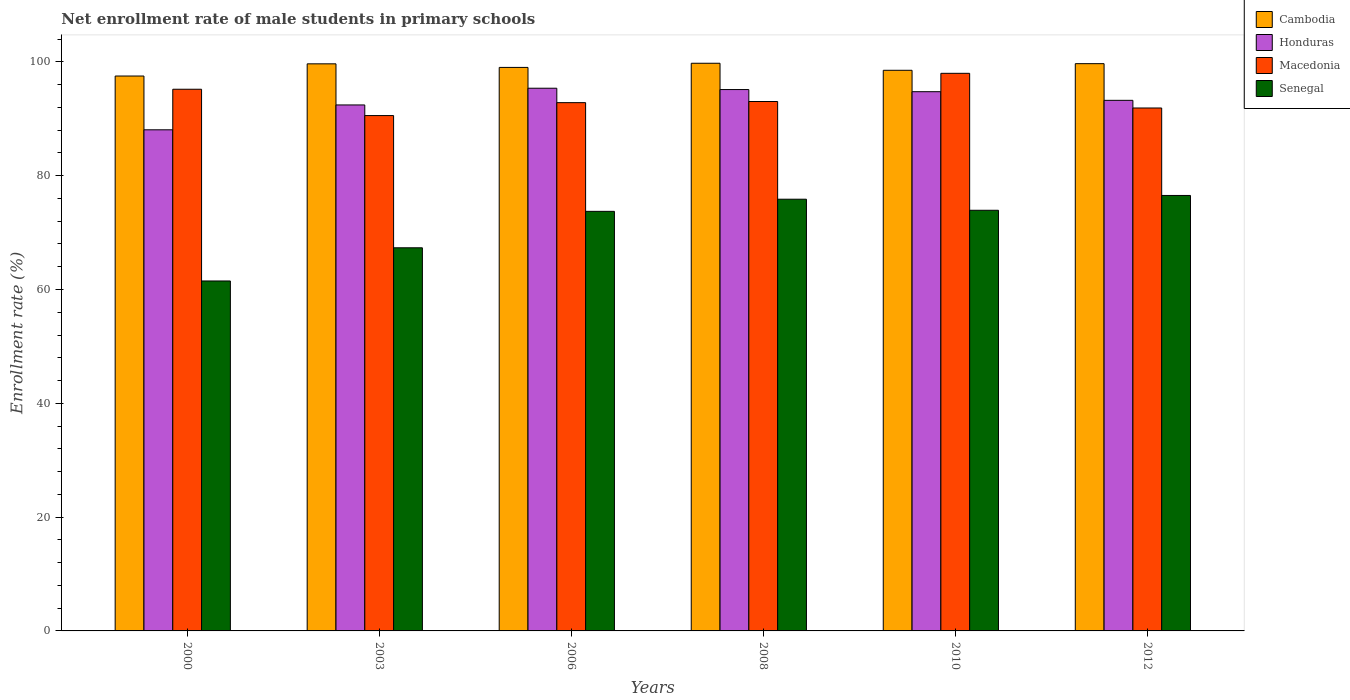How many groups of bars are there?
Offer a very short reply. 6. Are the number of bars per tick equal to the number of legend labels?
Your answer should be very brief. Yes. How many bars are there on the 5th tick from the right?
Your answer should be very brief. 4. What is the label of the 1st group of bars from the left?
Your response must be concise. 2000. What is the net enrollment rate of male students in primary schools in Macedonia in 2010?
Your answer should be very brief. 97.98. Across all years, what is the maximum net enrollment rate of male students in primary schools in Senegal?
Ensure brevity in your answer.  76.52. Across all years, what is the minimum net enrollment rate of male students in primary schools in Honduras?
Your answer should be compact. 88.06. In which year was the net enrollment rate of male students in primary schools in Senegal minimum?
Provide a succinct answer. 2000. What is the total net enrollment rate of male students in primary schools in Cambodia in the graph?
Offer a terse response. 594.13. What is the difference between the net enrollment rate of male students in primary schools in Honduras in 2006 and that in 2012?
Make the answer very short. 2.13. What is the difference between the net enrollment rate of male students in primary schools in Senegal in 2010 and the net enrollment rate of male students in primary schools in Macedonia in 2003?
Ensure brevity in your answer.  -16.64. What is the average net enrollment rate of male students in primary schools in Honduras per year?
Give a very brief answer. 93.16. In the year 2010, what is the difference between the net enrollment rate of male students in primary schools in Honduras and net enrollment rate of male students in primary schools in Cambodia?
Your answer should be very brief. -3.76. In how many years, is the net enrollment rate of male students in primary schools in Cambodia greater than 8 %?
Keep it short and to the point. 6. What is the ratio of the net enrollment rate of male students in primary schools in Honduras in 2000 to that in 2006?
Ensure brevity in your answer.  0.92. Is the difference between the net enrollment rate of male students in primary schools in Honduras in 2006 and 2012 greater than the difference between the net enrollment rate of male students in primary schools in Cambodia in 2006 and 2012?
Ensure brevity in your answer.  Yes. What is the difference between the highest and the second highest net enrollment rate of male students in primary schools in Honduras?
Provide a succinct answer. 0.24. What is the difference between the highest and the lowest net enrollment rate of male students in primary schools in Macedonia?
Your answer should be compact. 7.43. In how many years, is the net enrollment rate of male students in primary schools in Senegal greater than the average net enrollment rate of male students in primary schools in Senegal taken over all years?
Provide a short and direct response. 4. Is it the case that in every year, the sum of the net enrollment rate of male students in primary schools in Cambodia and net enrollment rate of male students in primary schools in Macedonia is greater than the sum of net enrollment rate of male students in primary schools in Senegal and net enrollment rate of male students in primary schools in Honduras?
Offer a terse response. No. What does the 4th bar from the left in 2006 represents?
Ensure brevity in your answer.  Senegal. What does the 4th bar from the right in 2003 represents?
Your response must be concise. Cambodia. Are all the bars in the graph horizontal?
Offer a terse response. No. How many years are there in the graph?
Give a very brief answer. 6. Does the graph contain any zero values?
Offer a very short reply. No. Where does the legend appear in the graph?
Offer a very short reply. Top right. How many legend labels are there?
Make the answer very short. 4. What is the title of the graph?
Ensure brevity in your answer.  Net enrollment rate of male students in primary schools. Does "Swaziland" appear as one of the legend labels in the graph?
Your answer should be compact. No. What is the label or title of the X-axis?
Make the answer very short. Years. What is the label or title of the Y-axis?
Keep it short and to the point. Enrollment rate (%). What is the Enrollment rate (%) of Cambodia in 2000?
Your response must be concise. 97.51. What is the Enrollment rate (%) in Honduras in 2000?
Make the answer very short. 88.06. What is the Enrollment rate (%) of Macedonia in 2000?
Your answer should be compact. 95.18. What is the Enrollment rate (%) of Senegal in 2000?
Provide a short and direct response. 61.49. What is the Enrollment rate (%) in Cambodia in 2003?
Offer a terse response. 99.65. What is the Enrollment rate (%) of Honduras in 2003?
Keep it short and to the point. 92.43. What is the Enrollment rate (%) of Macedonia in 2003?
Offer a terse response. 90.56. What is the Enrollment rate (%) in Senegal in 2003?
Provide a short and direct response. 67.33. What is the Enrollment rate (%) of Cambodia in 2006?
Keep it short and to the point. 99.02. What is the Enrollment rate (%) of Honduras in 2006?
Ensure brevity in your answer.  95.37. What is the Enrollment rate (%) of Macedonia in 2006?
Your answer should be compact. 92.83. What is the Enrollment rate (%) in Senegal in 2006?
Ensure brevity in your answer.  73.73. What is the Enrollment rate (%) in Cambodia in 2008?
Offer a very short reply. 99.75. What is the Enrollment rate (%) of Honduras in 2008?
Provide a short and direct response. 95.13. What is the Enrollment rate (%) of Macedonia in 2008?
Give a very brief answer. 93.03. What is the Enrollment rate (%) in Senegal in 2008?
Give a very brief answer. 75.86. What is the Enrollment rate (%) of Cambodia in 2010?
Provide a succinct answer. 98.52. What is the Enrollment rate (%) of Honduras in 2010?
Your answer should be compact. 94.75. What is the Enrollment rate (%) of Macedonia in 2010?
Offer a terse response. 97.98. What is the Enrollment rate (%) of Senegal in 2010?
Keep it short and to the point. 73.92. What is the Enrollment rate (%) in Cambodia in 2012?
Offer a very short reply. 99.68. What is the Enrollment rate (%) of Honduras in 2012?
Offer a very short reply. 93.24. What is the Enrollment rate (%) of Macedonia in 2012?
Provide a short and direct response. 91.89. What is the Enrollment rate (%) of Senegal in 2012?
Offer a terse response. 76.52. Across all years, what is the maximum Enrollment rate (%) of Cambodia?
Provide a succinct answer. 99.75. Across all years, what is the maximum Enrollment rate (%) of Honduras?
Your answer should be compact. 95.37. Across all years, what is the maximum Enrollment rate (%) of Macedonia?
Your answer should be very brief. 97.98. Across all years, what is the maximum Enrollment rate (%) in Senegal?
Provide a succinct answer. 76.52. Across all years, what is the minimum Enrollment rate (%) of Cambodia?
Keep it short and to the point. 97.51. Across all years, what is the minimum Enrollment rate (%) of Honduras?
Give a very brief answer. 88.06. Across all years, what is the minimum Enrollment rate (%) in Macedonia?
Give a very brief answer. 90.56. Across all years, what is the minimum Enrollment rate (%) in Senegal?
Your answer should be very brief. 61.49. What is the total Enrollment rate (%) in Cambodia in the graph?
Your response must be concise. 594.13. What is the total Enrollment rate (%) of Honduras in the graph?
Ensure brevity in your answer.  558.97. What is the total Enrollment rate (%) in Macedonia in the graph?
Give a very brief answer. 561.48. What is the total Enrollment rate (%) in Senegal in the graph?
Your answer should be compact. 428.85. What is the difference between the Enrollment rate (%) in Cambodia in 2000 and that in 2003?
Offer a terse response. -2.14. What is the difference between the Enrollment rate (%) of Honduras in 2000 and that in 2003?
Keep it short and to the point. -4.37. What is the difference between the Enrollment rate (%) in Macedonia in 2000 and that in 2003?
Your answer should be very brief. 4.63. What is the difference between the Enrollment rate (%) of Senegal in 2000 and that in 2003?
Offer a very short reply. -5.83. What is the difference between the Enrollment rate (%) of Cambodia in 2000 and that in 2006?
Keep it short and to the point. -1.51. What is the difference between the Enrollment rate (%) in Honduras in 2000 and that in 2006?
Keep it short and to the point. -7.31. What is the difference between the Enrollment rate (%) in Macedonia in 2000 and that in 2006?
Your answer should be compact. 2.36. What is the difference between the Enrollment rate (%) in Senegal in 2000 and that in 2006?
Your response must be concise. -12.24. What is the difference between the Enrollment rate (%) of Cambodia in 2000 and that in 2008?
Give a very brief answer. -2.24. What is the difference between the Enrollment rate (%) in Honduras in 2000 and that in 2008?
Make the answer very short. -7.07. What is the difference between the Enrollment rate (%) in Macedonia in 2000 and that in 2008?
Provide a short and direct response. 2.15. What is the difference between the Enrollment rate (%) of Senegal in 2000 and that in 2008?
Ensure brevity in your answer.  -14.37. What is the difference between the Enrollment rate (%) of Cambodia in 2000 and that in 2010?
Provide a short and direct response. -1.01. What is the difference between the Enrollment rate (%) in Honduras in 2000 and that in 2010?
Provide a succinct answer. -6.7. What is the difference between the Enrollment rate (%) of Macedonia in 2000 and that in 2010?
Ensure brevity in your answer.  -2.8. What is the difference between the Enrollment rate (%) of Senegal in 2000 and that in 2010?
Provide a succinct answer. -12.42. What is the difference between the Enrollment rate (%) of Cambodia in 2000 and that in 2012?
Offer a very short reply. -2.17. What is the difference between the Enrollment rate (%) in Honduras in 2000 and that in 2012?
Your answer should be very brief. -5.18. What is the difference between the Enrollment rate (%) of Macedonia in 2000 and that in 2012?
Your answer should be compact. 3.29. What is the difference between the Enrollment rate (%) of Senegal in 2000 and that in 2012?
Your answer should be very brief. -15.03. What is the difference between the Enrollment rate (%) in Cambodia in 2003 and that in 2006?
Ensure brevity in your answer.  0.63. What is the difference between the Enrollment rate (%) of Honduras in 2003 and that in 2006?
Provide a succinct answer. -2.94. What is the difference between the Enrollment rate (%) of Macedonia in 2003 and that in 2006?
Keep it short and to the point. -2.27. What is the difference between the Enrollment rate (%) of Senegal in 2003 and that in 2006?
Your response must be concise. -6.4. What is the difference between the Enrollment rate (%) of Cambodia in 2003 and that in 2008?
Offer a very short reply. -0.1. What is the difference between the Enrollment rate (%) of Honduras in 2003 and that in 2008?
Give a very brief answer. -2.7. What is the difference between the Enrollment rate (%) of Macedonia in 2003 and that in 2008?
Offer a terse response. -2.47. What is the difference between the Enrollment rate (%) in Senegal in 2003 and that in 2008?
Your answer should be compact. -8.54. What is the difference between the Enrollment rate (%) of Cambodia in 2003 and that in 2010?
Provide a succinct answer. 1.13. What is the difference between the Enrollment rate (%) of Honduras in 2003 and that in 2010?
Ensure brevity in your answer.  -2.33. What is the difference between the Enrollment rate (%) of Macedonia in 2003 and that in 2010?
Provide a short and direct response. -7.43. What is the difference between the Enrollment rate (%) in Senegal in 2003 and that in 2010?
Make the answer very short. -6.59. What is the difference between the Enrollment rate (%) of Cambodia in 2003 and that in 2012?
Provide a short and direct response. -0.03. What is the difference between the Enrollment rate (%) of Honduras in 2003 and that in 2012?
Make the answer very short. -0.81. What is the difference between the Enrollment rate (%) in Macedonia in 2003 and that in 2012?
Your answer should be very brief. -1.33. What is the difference between the Enrollment rate (%) in Senegal in 2003 and that in 2012?
Your answer should be compact. -9.2. What is the difference between the Enrollment rate (%) in Cambodia in 2006 and that in 2008?
Keep it short and to the point. -0.73. What is the difference between the Enrollment rate (%) in Honduras in 2006 and that in 2008?
Offer a very short reply. 0.24. What is the difference between the Enrollment rate (%) in Macedonia in 2006 and that in 2008?
Provide a short and direct response. -0.2. What is the difference between the Enrollment rate (%) of Senegal in 2006 and that in 2008?
Offer a very short reply. -2.13. What is the difference between the Enrollment rate (%) in Cambodia in 2006 and that in 2010?
Keep it short and to the point. 0.51. What is the difference between the Enrollment rate (%) in Honduras in 2006 and that in 2010?
Ensure brevity in your answer.  0.61. What is the difference between the Enrollment rate (%) in Macedonia in 2006 and that in 2010?
Your answer should be very brief. -5.15. What is the difference between the Enrollment rate (%) of Senegal in 2006 and that in 2010?
Your answer should be very brief. -0.19. What is the difference between the Enrollment rate (%) of Cambodia in 2006 and that in 2012?
Your response must be concise. -0.66. What is the difference between the Enrollment rate (%) of Honduras in 2006 and that in 2012?
Provide a short and direct response. 2.13. What is the difference between the Enrollment rate (%) in Macedonia in 2006 and that in 2012?
Offer a very short reply. 0.94. What is the difference between the Enrollment rate (%) of Senegal in 2006 and that in 2012?
Make the answer very short. -2.79. What is the difference between the Enrollment rate (%) of Cambodia in 2008 and that in 2010?
Offer a very short reply. 1.24. What is the difference between the Enrollment rate (%) in Honduras in 2008 and that in 2010?
Provide a short and direct response. 0.38. What is the difference between the Enrollment rate (%) of Macedonia in 2008 and that in 2010?
Offer a terse response. -4.95. What is the difference between the Enrollment rate (%) of Senegal in 2008 and that in 2010?
Provide a succinct answer. 1.95. What is the difference between the Enrollment rate (%) in Cambodia in 2008 and that in 2012?
Keep it short and to the point. 0.07. What is the difference between the Enrollment rate (%) in Honduras in 2008 and that in 2012?
Your response must be concise. 1.89. What is the difference between the Enrollment rate (%) in Macedonia in 2008 and that in 2012?
Make the answer very short. 1.14. What is the difference between the Enrollment rate (%) of Senegal in 2008 and that in 2012?
Provide a short and direct response. -0.66. What is the difference between the Enrollment rate (%) in Cambodia in 2010 and that in 2012?
Your answer should be compact. -1.16. What is the difference between the Enrollment rate (%) of Honduras in 2010 and that in 2012?
Offer a very short reply. 1.52. What is the difference between the Enrollment rate (%) of Macedonia in 2010 and that in 2012?
Your response must be concise. 6.09. What is the difference between the Enrollment rate (%) of Senegal in 2010 and that in 2012?
Provide a succinct answer. -2.6. What is the difference between the Enrollment rate (%) of Cambodia in 2000 and the Enrollment rate (%) of Honduras in 2003?
Provide a succinct answer. 5.08. What is the difference between the Enrollment rate (%) of Cambodia in 2000 and the Enrollment rate (%) of Macedonia in 2003?
Provide a short and direct response. 6.95. What is the difference between the Enrollment rate (%) in Cambodia in 2000 and the Enrollment rate (%) in Senegal in 2003?
Your response must be concise. 30.18. What is the difference between the Enrollment rate (%) in Honduras in 2000 and the Enrollment rate (%) in Macedonia in 2003?
Make the answer very short. -2.5. What is the difference between the Enrollment rate (%) in Honduras in 2000 and the Enrollment rate (%) in Senegal in 2003?
Provide a succinct answer. 20.73. What is the difference between the Enrollment rate (%) of Macedonia in 2000 and the Enrollment rate (%) of Senegal in 2003?
Offer a very short reply. 27.86. What is the difference between the Enrollment rate (%) of Cambodia in 2000 and the Enrollment rate (%) of Honduras in 2006?
Offer a very short reply. 2.14. What is the difference between the Enrollment rate (%) in Cambodia in 2000 and the Enrollment rate (%) in Macedonia in 2006?
Offer a very short reply. 4.68. What is the difference between the Enrollment rate (%) of Cambodia in 2000 and the Enrollment rate (%) of Senegal in 2006?
Give a very brief answer. 23.78. What is the difference between the Enrollment rate (%) of Honduras in 2000 and the Enrollment rate (%) of Macedonia in 2006?
Your answer should be compact. -4.77. What is the difference between the Enrollment rate (%) of Honduras in 2000 and the Enrollment rate (%) of Senegal in 2006?
Ensure brevity in your answer.  14.33. What is the difference between the Enrollment rate (%) in Macedonia in 2000 and the Enrollment rate (%) in Senegal in 2006?
Ensure brevity in your answer.  21.45. What is the difference between the Enrollment rate (%) of Cambodia in 2000 and the Enrollment rate (%) of Honduras in 2008?
Your answer should be compact. 2.38. What is the difference between the Enrollment rate (%) of Cambodia in 2000 and the Enrollment rate (%) of Macedonia in 2008?
Your answer should be compact. 4.48. What is the difference between the Enrollment rate (%) in Cambodia in 2000 and the Enrollment rate (%) in Senegal in 2008?
Offer a terse response. 21.65. What is the difference between the Enrollment rate (%) of Honduras in 2000 and the Enrollment rate (%) of Macedonia in 2008?
Provide a short and direct response. -4.97. What is the difference between the Enrollment rate (%) in Honduras in 2000 and the Enrollment rate (%) in Senegal in 2008?
Your response must be concise. 12.2. What is the difference between the Enrollment rate (%) of Macedonia in 2000 and the Enrollment rate (%) of Senegal in 2008?
Provide a succinct answer. 19.32. What is the difference between the Enrollment rate (%) in Cambodia in 2000 and the Enrollment rate (%) in Honduras in 2010?
Offer a terse response. 2.75. What is the difference between the Enrollment rate (%) of Cambodia in 2000 and the Enrollment rate (%) of Macedonia in 2010?
Make the answer very short. -0.48. What is the difference between the Enrollment rate (%) in Cambodia in 2000 and the Enrollment rate (%) in Senegal in 2010?
Your answer should be compact. 23.59. What is the difference between the Enrollment rate (%) of Honduras in 2000 and the Enrollment rate (%) of Macedonia in 2010?
Your answer should be very brief. -9.93. What is the difference between the Enrollment rate (%) in Honduras in 2000 and the Enrollment rate (%) in Senegal in 2010?
Ensure brevity in your answer.  14.14. What is the difference between the Enrollment rate (%) in Macedonia in 2000 and the Enrollment rate (%) in Senegal in 2010?
Your answer should be compact. 21.27. What is the difference between the Enrollment rate (%) in Cambodia in 2000 and the Enrollment rate (%) in Honduras in 2012?
Offer a very short reply. 4.27. What is the difference between the Enrollment rate (%) in Cambodia in 2000 and the Enrollment rate (%) in Macedonia in 2012?
Provide a short and direct response. 5.62. What is the difference between the Enrollment rate (%) of Cambodia in 2000 and the Enrollment rate (%) of Senegal in 2012?
Offer a very short reply. 20.99. What is the difference between the Enrollment rate (%) of Honduras in 2000 and the Enrollment rate (%) of Macedonia in 2012?
Offer a very short reply. -3.83. What is the difference between the Enrollment rate (%) of Honduras in 2000 and the Enrollment rate (%) of Senegal in 2012?
Provide a succinct answer. 11.54. What is the difference between the Enrollment rate (%) of Macedonia in 2000 and the Enrollment rate (%) of Senegal in 2012?
Give a very brief answer. 18.66. What is the difference between the Enrollment rate (%) of Cambodia in 2003 and the Enrollment rate (%) of Honduras in 2006?
Your answer should be very brief. 4.28. What is the difference between the Enrollment rate (%) in Cambodia in 2003 and the Enrollment rate (%) in Macedonia in 2006?
Your response must be concise. 6.82. What is the difference between the Enrollment rate (%) of Cambodia in 2003 and the Enrollment rate (%) of Senegal in 2006?
Keep it short and to the point. 25.92. What is the difference between the Enrollment rate (%) in Honduras in 2003 and the Enrollment rate (%) in Macedonia in 2006?
Provide a succinct answer. -0.4. What is the difference between the Enrollment rate (%) in Honduras in 2003 and the Enrollment rate (%) in Senegal in 2006?
Keep it short and to the point. 18.7. What is the difference between the Enrollment rate (%) of Macedonia in 2003 and the Enrollment rate (%) of Senegal in 2006?
Offer a very short reply. 16.83. What is the difference between the Enrollment rate (%) of Cambodia in 2003 and the Enrollment rate (%) of Honduras in 2008?
Offer a terse response. 4.52. What is the difference between the Enrollment rate (%) in Cambodia in 2003 and the Enrollment rate (%) in Macedonia in 2008?
Offer a very short reply. 6.62. What is the difference between the Enrollment rate (%) in Cambodia in 2003 and the Enrollment rate (%) in Senegal in 2008?
Ensure brevity in your answer.  23.79. What is the difference between the Enrollment rate (%) in Honduras in 2003 and the Enrollment rate (%) in Macedonia in 2008?
Make the answer very short. -0.6. What is the difference between the Enrollment rate (%) in Honduras in 2003 and the Enrollment rate (%) in Senegal in 2008?
Offer a very short reply. 16.57. What is the difference between the Enrollment rate (%) in Macedonia in 2003 and the Enrollment rate (%) in Senegal in 2008?
Offer a terse response. 14.7. What is the difference between the Enrollment rate (%) of Cambodia in 2003 and the Enrollment rate (%) of Honduras in 2010?
Provide a short and direct response. 4.9. What is the difference between the Enrollment rate (%) of Cambodia in 2003 and the Enrollment rate (%) of Macedonia in 2010?
Offer a terse response. 1.67. What is the difference between the Enrollment rate (%) of Cambodia in 2003 and the Enrollment rate (%) of Senegal in 2010?
Your answer should be very brief. 25.73. What is the difference between the Enrollment rate (%) in Honduras in 2003 and the Enrollment rate (%) in Macedonia in 2010?
Provide a succinct answer. -5.56. What is the difference between the Enrollment rate (%) of Honduras in 2003 and the Enrollment rate (%) of Senegal in 2010?
Ensure brevity in your answer.  18.51. What is the difference between the Enrollment rate (%) in Macedonia in 2003 and the Enrollment rate (%) in Senegal in 2010?
Provide a succinct answer. 16.64. What is the difference between the Enrollment rate (%) in Cambodia in 2003 and the Enrollment rate (%) in Honduras in 2012?
Your answer should be compact. 6.41. What is the difference between the Enrollment rate (%) in Cambodia in 2003 and the Enrollment rate (%) in Macedonia in 2012?
Your answer should be compact. 7.76. What is the difference between the Enrollment rate (%) in Cambodia in 2003 and the Enrollment rate (%) in Senegal in 2012?
Your response must be concise. 23.13. What is the difference between the Enrollment rate (%) of Honduras in 2003 and the Enrollment rate (%) of Macedonia in 2012?
Offer a very short reply. 0.54. What is the difference between the Enrollment rate (%) in Honduras in 2003 and the Enrollment rate (%) in Senegal in 2012?
Give a very brief answer. 15.91. What is the difference between the Enrollment rate (%) in Macedonia in 2003 and the Enrollment rate (%) in Senegal in 2012?
Your answer should be compact. 14.04. What is the difference between the Enrollment rate (%) in Cambodia in 2006 and the Enrollment rate (%) in Honduras in 2008?
Offer a very short reply. 3.89. What is the difference between the Enrollment rate (%) of Cambodia in 2006 and the Enrollment rate (%) of Macedonia in 2008?
Ensure brevity in your answer.  5.99. What is the difference between the Enrollment rate (%) of Cambodia in 2006 and the Enrollment rate (%) of Senegal in 2008?
Offer a terse response. 23.16. What is the difference between the Enrollment rate (%) in Honduras in 2006 and the Enrollment rate (%) in Macedonia in 2008?
Provide a succinct answer. 2.33. What is the difference between the Enrollment rate (%) in Honduras in 2006 and the Enrollment rate (%) in Senegal in 2008?
Make the answer very short. 19.5. What is the difference between the Enrollment rate (%) of Macedonia in 2006 and the Enrollment rate (%) of Senegal in 2008?
Your response must be concise. 16.97. What is the difference between the Enrollment rate (%) of Cambodia in 2006 and the Enrollment rate (%) of Honduras in 2010?
Provide a short and direct response. 4.27. What is the difference between the Enrollment rate (%) in Cambodia in 2006 and the Enrollment rate (%) in Macedonia in 2010?
Offer a terse response. 1.04. What is the difference between the Enrollment rate (%) of Cambodia in 2006 and the Enrollment rate (%) of Senegal in 2010?
Offer a terse response. 25.11. What is the difference between the Enrollment rate (%) in Honduras in 2006 and the Enrollment rate (%) in Macedonia in 2010?
Keep it short and to the point. -2.62. What is the difference between the Enrollment rate (%) in Honduras in 2006 and the Enrollment rate (%) in Senegal in 2010?
Provide a short and direct response. 21.45. What is the difference between the Enrollment rate (%) in Macedonia in 2006 and the Enrollment rate (%) in Senegal in 2010?
Give a very brief answer. 18.91. What is the difference between the Enrollment rate (%) of Cambodia in 2006 and the Enrollment rate (%) of Honduras in 2012?
Keep it short and to the point. 5.79. What is the difference between the Enrollment rate (%) of Cambodia in 2006 and the Enrollment rate (%) of Macedonia in 2012?
Offer a terse response. 7.13. What is the difference between the Enrollment rate (%) in Cambodia in 2006 and the Enrollment rate (%) in Senegal in 2012?
Your answer should be very brief. 22.5. What is the difference between the Enrollment rate (%) in Honduras in 2006 and the Enrollment rate (%) in Macedonia in 2012?
Give a very brief answer. 3.47. What is the difference between the Enrollment rate (%) of Honduras in 2006 and the Enrollment rate (%) of Senegal in 2012?
Offer a very short reply. 18.84. What is the difference between the Enrollment rate (%) in Macedonia in 2006 and the Enrollment rate (%) in Senegal in 2012?
Your answer should be very brief. 16.31. What is the difference between the Enrollment rate (%) in Cambodia in 2008 and the Enrollment rate (%) in Honduras in 2010?
Ensure brevity in your answer.  5. What is the difference between the Enrollment rate (%) of Cambodia in 2008 and the Enrollment rate (%) of Macedonia in 2010?
Make the answer very short. 1.77. What is the difference between the Enrollment rate (%) of Cambodia in 2008 and the Enrollment rate (%) of Senegal in 2010?
Keep it short and to the point. 25.84. What is the difference between the Enrollment rate (%) of Honduras in 2008 and the Enrollment rate (%) of Macedonia in 2010?
Make the answer very short. -2.85. What is the difference between the Enrollment rate (%) of Honduras in 2008 and the Enrollment rate (%) of Senegal in 2010?
Make the answer very short. 21.21. What is the difference between the Enrollment rate (%) of Macedonia in 2008 and the Enrollment rate (%) of Senegal in 2010?
Make the answer very short. 19.11. What is the difference between the Enrollment rate (%) of Cambodia in 2008 and the Enrollment rate (%) of Honduras in 2012?
Provide a short and direct response. 6.52. What is the difference between the Enrollment rate (%) in Cambodia in 2008 and the Enrollment rate (%) in Macedonia in 2012?
Offer a very short reply. 7.86. What is the difference between the Enrollment rate (%) in Cambodia in 2008 and the Enrollment rate (%) in Senegal in 2012?
Offer a terse response. 23.23. What is the difference between the Enrollment rate (%) of Honduras in 2008 and the Enrollment rate (%) of Macedonia in 2012?
Your answer should be very brief. 3.24. What is the difference between the Enrollment rate (%) of Honduras in 2008 and the Enrollment rate (%) of Senegal in 2012?
Provide a succinct answer. 18.61. What is the difference between the Enrollment rate (%) in Macedonia in 2008 and the Enrollment rate (%) in Senegal in 2012?
Your answer should be compact. 16.51. What is the difference between the Enrollment rate (%) of Cambodia in 2010 and the Enrollment rate (%) of Honduras in 2012?
Offer a terse response. 5.28. What is the difference between the Enrollment rate (%) of Cambodia in 2010 and the Enrollment rate (%) of Macedonia in 2012?
Offer a terse response. 6.63. What is the difference between the Enrollment rate (%) in Cambodia in 2010 and the Enrollment rate (%) in Senegal in 2012?
Provide a succinct answer. 22. What is the difference between the Enrollment rate (%) in Honduras in 2010 and the Enrollment rate (%) in Macedonia in 2012?
Give a very brief answer. 2.86. What is the difference between the Enrollment rate (%) in Honduras in 2010 and the Enrollment rate (%) in Senegal in 2012?
Offer a terse response. 18.23. What is the difference between the Enrollment rate (%) in Macedonia in 2010 and the Enrollment rate (%) in Senegal in 2012?
Offer a terse response. 21.46. What is the average Enrollment rate (%) in Cambodia per year?
Make the answer very short. 99.02. What is the average Enrollment rate (%) of Honduras per year?
Give a very brief answer. 93.16. What is the average Enrollment rate (%) in Macedonia per year?
Ensure brevity in your answer.  93.58. What is the average Enrollment rate (%) in Senegal per year?
Provide a succinct answer. 71.48. In the year 2000, what is the difference between the Enrollment rate (%) of Cambodia and Enrollment rate (%) of Honduras?
Your answer should be very brief. 9.45. In the year 2000, what is the difference between the Enrollment rate (%) in Cambodia and Enrollment rate (%) in Macedonia?
Offer a very short reply. 2.32. In the year 2000, what is the difference between the Enrollment rate (%) in Cambodia and Enrollment rate (%) in Senegal?
Your response must be concise. 36.01. In the year 2000, what is the difference between the Enrollment rate (%) in Honduras and Enrollment rate (%) in Macedonia?
Ensure brevity in your answer.  -7.13. In the year 2000, what is the difference between the Enrollment rate (%) in Honduras and Enrollment rate (%) in Senegal?
Keep it short and to the point. 26.56. In the year 2000, what is the difference between the Enrollment rate (%) of Macedonia and Enrollment rate (%) of Senegal?
Provide a succinct answer. 33.69. In the year 2003, what is the difference between the Enrollment rate (%) of Cambodia and Enrollment rate (%) of Honduras?
Offer a terse response. 7.22. In the year 2003, what is the difference between the Enrollment rate (%) of Cambodia and Enrollment rate (%) of Macedonia?
Make the answer very short. 9.09. In the year 2003, what is the difference between the Enrollment rate (%) of Cambodia and Enrollment rate (%) of Senegal?
Your response must be concise. 32.32. In the year 2003, what is the difference between the Enrollment rate (%) in Honduras and Enrollment rate (%) in Macedonia?
Give a very brief answer. 1.87. In the year 2003, what is the difference between the Enrollment rate (%) of Honduras and Enrollment rate (%) of Senegal?
Provide a short and direct response. 25.1. In the year 2003, what is the difference between the Enrollment rate (%) of Macedonia and Enrollment rate (%) of Senegal?
Your response must be concise. 23.23. In the year 2006, what is the difference between the Enrollment rate (%) in Cambodia and Enrollment rate (%) in Honduras?
Provide a short and direct response. 3.66. In the year 2006, what is the difference between the Enrollment rate (%) in Cambodia and Enrollment rate (%) in Macedonia?
Your answer should be very brief. 6.19. In the year 2006, what is the difference between the Enrollment rate (%) in Cambodia and Enrollment rate (%) in Senegal?
Your answer should be very brief. 25.29. In the year 2006, what is the difference between the Enrollment rate (%) in Honduras and Enrollment rate (%) in Macedonia?
Offer a terse response. 2.54. In the year 2006, what is the difference between the Enrollment rate (%) of Honduras and Enrollment rate (%) of Senegal?
Provide a succinct answer. 21.64. In the year 2006, what is the difference between the Enrollment rate (%) in Macedonia and Enrollment rate (%) in Senegal?
Make the answer very short. 19.1. In the year 2008, what is the difference between the Enrollment rate (%) in Cambodia and Enrollment rate (%) in Honduras?
Provide a short and direct response. 4.62. In the year 2008, what is the difference between the Enrollment rate (%) in Cambodia and Enrollment rate (%) in Macedonia?
Offer a terse response. 6.72. In the year 2008, what is the difference between the Enrollment rate (%) of Cambodia and Enrollment rate (%) of Senegal?
Your answer should be very brief. 23.89. In the year 2008, what is the difference between the Enrollment rate (%) of Honduras and Enrollment rate (%) of Macedonia?
Ensure brevity in your answer.  2.1. In the year 2008, what is the difference between the Enrollment rate (%) in Honduras and Enrollment rate (%) in Senegal?
Provide a succinct answer. 19.27. In the year 2008, what is the difference between the Enrollment rate (%) of Macedonia and Enrollment rate (%) of Senegal?
Ensure brevity in your answer.  17.17. In the year 2010, what is the difference between the Enrollment rate (%) in Cambodia and Enrollment rate (%) in Honduras?
Your answer should be very brief. 3.76. In the year 2010, what is the difference between the Enrollment rate (%) in Cambodia and Enrollment rate (%) in Macedonia?
Your answer should be compact. 0.53. In the year 2010, what is the difference between the Enrollment rate (%) in Cambodia and Enrollment rate (%) in Senegal?
Offer a terse response. 24.6. In the year 2010, what is the difference between the Enrollment rate (%) in Honduras and Enrollment rate (%) in Macedonia?
Provide a succinct answer. -3.23. In the year 2010, what is the difference between the Enrollment rate (%) of Honduras and Enrollment rate (%) of Senegal?
Provide a succinct answer. 20.84. In the year 2010, what is the difference between the Enrollment rate (%) of Macedonia and Enrollment rate (%) of Senegal?
Your answer should be very brief. 24.07. In the year 2012, what is the difference between the Enrollment rate (%) of Cambodia and Enrollment rate (%) of Honduras?
Keep it short and to the point. 6.44. In the year 2012, what is the difference between the Enrollment rate (%) of Cambodia and Enrollment rate (%) of Macedonia?
Provide a short and direct response. 7.79. In the year 2012, what is the difference between the Enrollment rate (%) of Cambodia and Enrollment rate (%) of Senegal?
Provide a succinct answer. 23.16. In the year 2012, what is the difference between the Enrollment rate (%) of Honduras and Enrollment rate (%) of Macedonia?
Your answer should be very brief. 1.34. In the year 2012, what is the difference between the Enrollment rate (%) in Honduras and Enrollment rate (%) in Senegal?
Ensure brevity in your answer.  16.71. In the year 2012, what is the difference between the Enrollment rate (%) of Macedonia and Enrollment rate (%) of Senegal?
Provide a succinct answer. 15.37. What is the ratio of the Enrollment rate (%) in Cambodia in 2000 to that in 2003?
Your answer should be very brief. 0.98. What is the ratio of the Enrollment rate (%) of Honduras in 2000 to that in 2003?
Provide a short and direct response. 0.95. What is the ratio of the Enrollment rate (%) in Macedonia in 2000 to that in 2003?
Ensure brevity in your answer.  1.05. What is the ratio of the Enrollment rate (%) of Senegal in 2000 to that in 2003?
Offer a very short reply. 0.91. What is the ratio of the Enrollment rate (%) in Cambodia in 2000 to that in 2006?
Your answer should be compact. 0.98. What is the ratio of the Enrollment rate (%) of Honduras in 2000 to that in 2006?
Ensure brevity in your answer.  0.92. What is the ratio of the Enrollment rate (%) of Macedonia in 2000 to that in 2006?
Provide a short and direct response. 1.03. What is the ratio of the Enrollment rate (%) in Senegal in 2000 to that in 2006?
Provide a succinct answer. 0.83. What is the ratio of the Enrollment rate (%) in Cambodia in 2000 to that in 2008?
Provide a short and direct response. 0.98. What is the ratio of the Enrollment rate (%) of Honduras in 2000 to that in 2008?
Make the answer very short. 0.93. What is the ratio of the Enrollment rate (%) in Macedonia in 2000 to that in 2008?
Keep it short and to the point. 1.02. What is the ratio of the Enrollment rate (%) in Senegal in 2000 to that in 2008?
Offer a terse response. 0.81. What is the ratio of the Enrollment rate (%) of Honduras in 2000 to that in 2010?
Your answer should be compact. 0.93. What is the ratio of the Enrollment rate (%) of Macedonia in 2000 to that in 2010?
Your answer should be compact. 0.97. What is the ratio of the Enrollment rate (%) in Senegal in 2000 to that in 2010?
Offer a terse response. 0.83. What is the ratio of the Enrollment rate (%) of Cambodia in 2000 to that in 2012?
Make the answer very short. 0.98. What is the ratio of the Enrollment rate (%) of Honduras in 2000 to that in 2012?
Your response must be concise. 0.94. What is the ratio of the Enrollment rate (%) of Macedonia in 2000 to that in 2012?
Provide a succinct answer. 1.04. What is the ratio of the Enrollment rate (%) of Senegal in 2000 to that in 2012?
Your answer should be compact. 0.8. What is the ratio of the Enrollment rate (%) in Honduras in 2003 to that in 2006?
Provide a succinct answer. 0.97. What is the ratio of the Enrollment rate (%) in Macedonia in 2003 to that in 2006?
Keep it short and to the point. 0.98. What is the ratio of the Enrollment rate (%) in Senegal in 2003 to that in 2006?
Your response must be concise. 0.91. What is the ratio of the Enrollment rate (%) of Honduras in 2003 to that in 2008?
Give a very brief answer. 0.97. What is the ratio of the Enrollment rate (%) in Macedonia in 2003 to that in 2008?
Offer a terse response. 0.97. What is the ratio of the Enrollment rate (%) in Senegal in 2003 to that in 2008?
Offer a very short reply. 0.89. What is the ratio of the Enrollment rate (%) in Cambodia in 2003 to that in 2010?
Offer a very short reply. 1.01. What is the ratio of the Enrollment rate (%) in Honduras in 2003 to that in 2010?
Ensure brevity in your answer.  0.98. What is the ratio of the Enrollment rate (%) of Macedonia in 2003 to that in 2010?
Offer a terse response. 0.92. What is the ratio of the Enrollment rate (%) in Senegal in 2003 to that in 2010?
Your answer should be compact. 0.91. What is the ratio of the Enrollment rate (%) in Macedonia in 2003 to that in 2012?
Provide a short and direct response. 0.99. What is the ratio of the Enrollment rate (%) of Senegal in 2003 to that in 2012?
Give a very brief answer. 0.88. What is the ratio of the Enrollment rate (%) in Cambodia in 2006 to that in 2008?
Provide a short and direct response. 0.99. What is the ratio of the Enrollment rate (%) of Honduras in 2006 to that in 2008?
Provide a short and direct response. 1. What is the ratio of the Enrollment rate (%) of Macedonia in 2006 to that in 2008?
Make the answer very short. 1. What is the ratio of the Enrollment rate (%) of Senegal in 2006 to that in 2008?
Ensure brevity in your answer.  0.97. What is the ratio of the Enrollment rate (%) in Honduras in 2006 to that in 2010?
Offer a terse response. 1.01. What is the ratio of the Enrollment rate (%) in Macedonia in 2006 to that in 2010?
Keep it short and to the point. 0.95. What is the ratio of the Enrollment rate (%) in Senegal in 2006 to that in 2010?
Give a very brief answer. 1. What is the ratio of the Enrollment rate (%) in Honduras in 2006 to that in 2012?
Keep it short and to the point. 1.02. What is the ratio of the Enrollment rate (%) of Macedonia in 2006 to that in 2012?
Your answer should be very brief. 1.01. What is the ratio of the Enrollment rate (%) in Senegal in 2006 to that in 2012?
Your answer should be compact. 0.96. What is the ratio of the Enrollment rate (%) of Cambodia in 2008 to that in 2010?
Offer a terse response. 1.01. What is the ratio of the Enrollment rate (%) of Macedonia in 2008 to that in 2010?
Make the answer very short. 0.95. What is the ratio of the Enrollment rate (%) in Senegal in 2008 to that in 2010?
Make the answer very short. 1.03. What is the ratio of the Enrollment rate (%) in Honduras in 2008 to that in 2012?
Ensure brevity in your answer.  1.02. What is the ratio of the Enrollment rate (%) in Macedonia in 2008 to that in 2012?
Keep it short and to the point. 1.01. What is the ratio of the Enrollment rate (%) in Cambodia in 2010 to that in 2012?
Offer a very short reply. 0.99. What is the ratio of the Enrollment rate (%) in Honduras in 2010 to that in 2012?
Keep it short and to the point. 1.02. What is the ratio of the Enrollment rate (%) in Macedonia in 2010 to that in 2012?
Your answer should be very brief. 1.07. What is the ratio of the Enrollment rate (%) of Senegal in 2010 to that in 2012?
Your answer should be compact. 0.97. What is the difference between the highest and the second highest Enrollment rate (%) in Cambodia?
Provide a short and direct response. 0.07. What is the difference between the highest and the second highest Enrollment rate (%) in Honduras?
Ensure brevity in your answer.  0.24. What is the difference between the highest and the second highest Enrollment rate (%) in Macedonia?
Your answer should be very brief. 2.8. What is the difference between the highest and the second highest Enrollment rate (%) of Senegal?
Provide a short and direct response. 0.66. What is the difference between the highest and the lowest Enrollment rate (%) in Cambodia?
Keep it short and to the point. 2.24. What is the difference between the highest and the lowest Enrollment rate (%) in Honduras?
Provide a succinct answer. 7.31. What is the difference between the highest and the lowest Enrollment rate (%) in Macedonia?
Ensure brevity in your answer.  7.43. What is the difference between the highest and the lowest Enrollment rate (%) of Senegal?
Give a very brief answer. 15.03. 